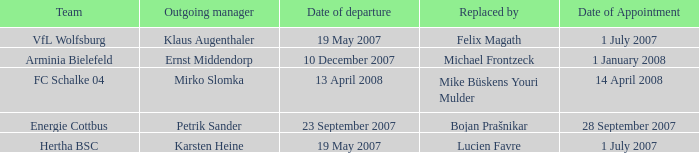When was the appointment date for the manager replaced by Lucien Favre? 1 July 2007. 